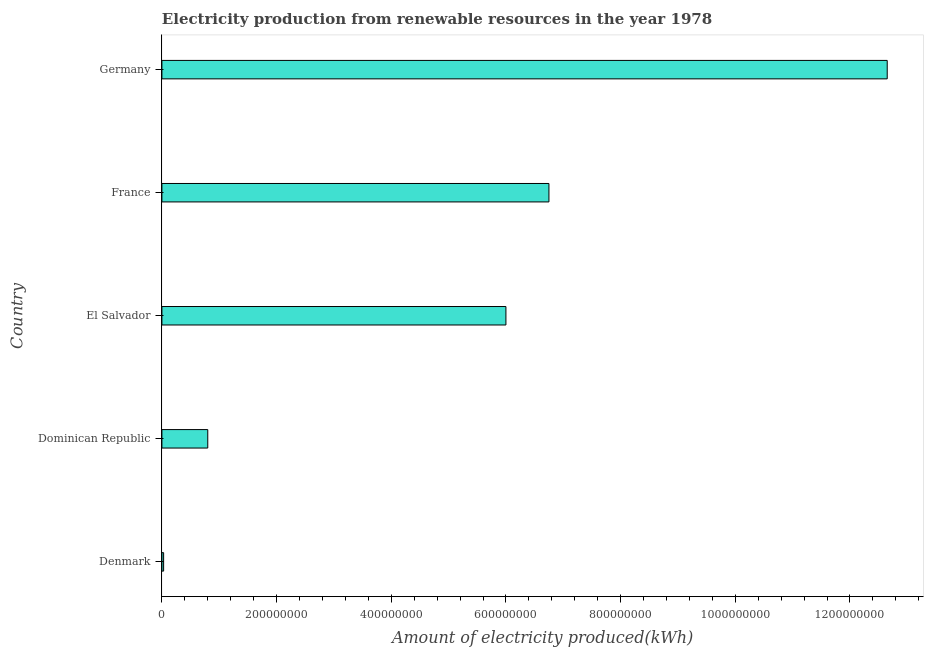Does the graph contain any zero values?
Provide a short and direct response. No. Does the graph contain grids?
Offer a terse response. No. What is the title of the graph?
Your answer should be very brief. Electricity production from renewable resources in the year 1978. What is the label or title of the X-axis?
Ensure brevity in your answer.  Amount of electricity produced(kWh). What is the label or title of the Y-axis?
Make the answer very short. Country. What is the amount of electricity produced in Germany?
Your answer should be very brief. 1.26e+09. Across all countries, what is the maximum amount of electricity produced?
Ensure brevity in your answer.  1.26e+09. Across all countries, what is the minimum amount of electricity produced?
Give a very brief answer. 3.00e+06. In which country was the amount of electricity produced maximum?
Offer a terse response. Germany. What is the sum of the amount of electricity produced?
Ensure brevity in your answer.  2.62e+09. What is the difference between the amount of electricity produced in Denmark and Dominican Republic?
Your answer should be compact. -7.70e+07. What is the average amount of electricity produced per country?
Your response must be concise. 5.25e+08. What is the median amount of electricity produced?
Ensure brevity in your answer.  6.00e+08. What is the ratio of the amount of electricity produced in El Salvador to that in Germany?
Your answer should be compact. 0.47. Is the difference between the amount of electricity produced in Dominican Republic and France greater than the difference between any two countries?
Offer a terse response. No. What is the difference between the highest and the second highest amount of electricity produced?
Provide a succinct answer. 5.90e+08. Is the sum of the amount of electricity produced in France and Germany greater than the maximum amount of electricity produced across all countries?
Provide a succinct answer. Yes. What is the difference between the highest and the lowest amount of electricity produced?
Provide a short and direct response. 1.26e+09. In how many countries, is the amount of electricity produced greater than the average amount of electricity produced taken over all countries?
Your answer should be very brief. 3. Are all the bars in the graph horizontal?
Your answer should be very brief. Yes. How many countries are there in the graph?
Provide a short and direct response. 5. What is the Amount of electricity produced(kWh) in Dominican Republic?
Your answer should be very brief. 8.00e+07. What is the Amount of electricity produced(kWh) in El Salvador?
Offer a terse response. 6.00e+08. What is the Amount of electricity produced(kWh) of France?
Keep it short and to the point. 6.75e+08. What is the Amount of electricity produced(kWh) in Germany?
Keep it short and to the point. 1.26e+09. What is the difference between the Amount of electricity produced(kWh) in Denmark and Dominican Republic?
Ensure brevity in your answer.  -7.70e+07. What is the difference between the Amount of electricity produced(kWh) in Denmark and El Salvador?
Offer a very short reply. -5.97e+08. What is the difference between the Amount of electricity produced(kWh) in Denmark and France?
Ensure brevity in your answer.  -6.72e+08. What is the difference between the Amount of electricity produced(kWh) in Denmark and Germany?
Make the answer very short. -1.26e+09. What is the difference between the Amount of electricity produced(kWh) in Dominican Republic and El Salvador?
Keep it short and to the point. -5.20e+08. What is the difference between the Amount of electricity produced(kWh) in Dominican Republic and France?
Your answer should be compact. -5.95e+08. What is the difference between the Amount of electricity produced(kWh) in Dominican Republic and Germany?
Provide a succinct answer. -1.18e+09. What is the difference between the Amount of electricity produced(kWh) in El Salvador and France?
Your response must be concise. -7.50e+07. What is the difference between the Amount of electricity produced(kWh) in El Salvador and Germany?
Your answer should be very brief. -6.65e+08. What is the difference between the Amount of electricity produced(kWh) in France and Germany?
Provide a short and direct response. -5.90e+08. What is the ratio of the Amount of electricity produced(kWh) in Denmark to that in Dominican Republic?
Offer a very short reply. 0.04. What is the ratio of the Amount of electricity produced(kWh) in Denmark to that in El Salvador?
Provide a short and direct response. 0.01. What is the ratio of the Amount of electricity produced(kWh) in Denmark to that in France?
Offer a very short reply. 0. What is the ratio of the Amount of electricity produced(kWh) in Denmark to that in Germany?
Offer a terse response. 0. What is the ratio of the Amount of electricity produced(kWh) in Dominican Republic to that in El Salvador?
Your response must be concise. 0.13. What is the ratio of the Amount of electricity produced(kWh) in Dominican Republic to that in France?
Make the answer very short. 0.12. What is the ratio of the Amount of electricity produced(kWh) in Dominican Republic to that in Germany?
Your answer should be compact. 0.06. What is the ratio of the Amount of electricity produced(kWh) in El Salvador to that in France?
Your response must be concise. 0.89. What is the ratio of the Amount of electricity produced(kWh) in El Salvador to that in Germany?
Offer a very short reply. 0.47. What is the ratio of the Amount of electricity produced(kWh) in France to that in Germany?
Make the answer very short. 0.53. 